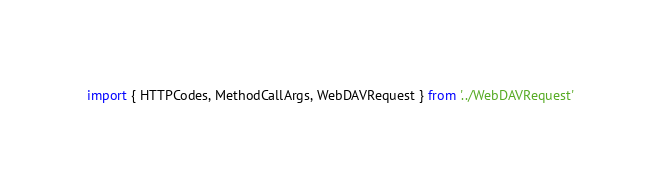Convert code to text. <code><loc_0><loc_0><loc_500><loc_500><_TypeScript_>import { HTTPCodes, MethodCallArgs, WebDAVRequest } from '../WebDAVRequest'</code> 